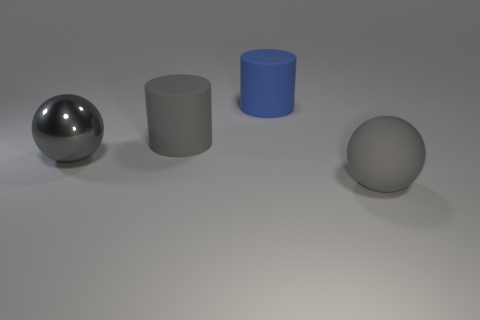Add 2 tiny blue balls. How many objects exist? 6 Subtract 1 spheres. How many spheres are left? 1 Subtract all blue cylinders. How many cylinders are left? 1 Subtract all gray cylinders. Subtract all gray cylinders. How many objects are left? 2 Add 2 large gray things. How many large gray things are left? 5 Add 3 gray objects. How many gray objects exist? 6 Subtract 0 cyan cylinders. How many objects are left? 4 Subtract all red spheres. Subtract all brown cubes. How many spheres are left? 2 Subtract all gray balls. How many purple cylinders are left? 0 